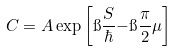Convert formula to latex. <formula><loc_0><loc_0><loc_500><loc_500>C = A \exp \left [ \i \frac { S } { \hbar } { - } \i \frac { \pi } { 2 } \mu \right ]</formula> 